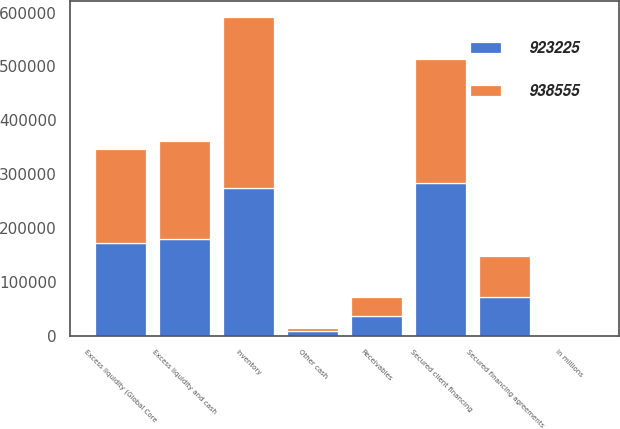Convert chart to OTSL. <chart><loc_0><loc_0><loc_500><loc_500><stacked_bar_chart><ecel><fcel>in millions<fcel>Excess liquidity (Global Core<fcel>Other cash<fcel>Excess liquidity and cash<fcel>Secured client financing<fcel>Inventory<fcel>Secured financing agreements<fcel>Receivables<nl><fcel>938555<fcel>2012<fcel>174622<fcel>6839<fcel>181461<fcel>229442<fcel>318323<fcel>76277<fcel>36273<nl><fcel>923225<fcel>2011<fcel>171581<fcel>7888<fcel>179469<fcel>283707<fcel>273640<fcel>71103<fcel>35769<nl></chart> 